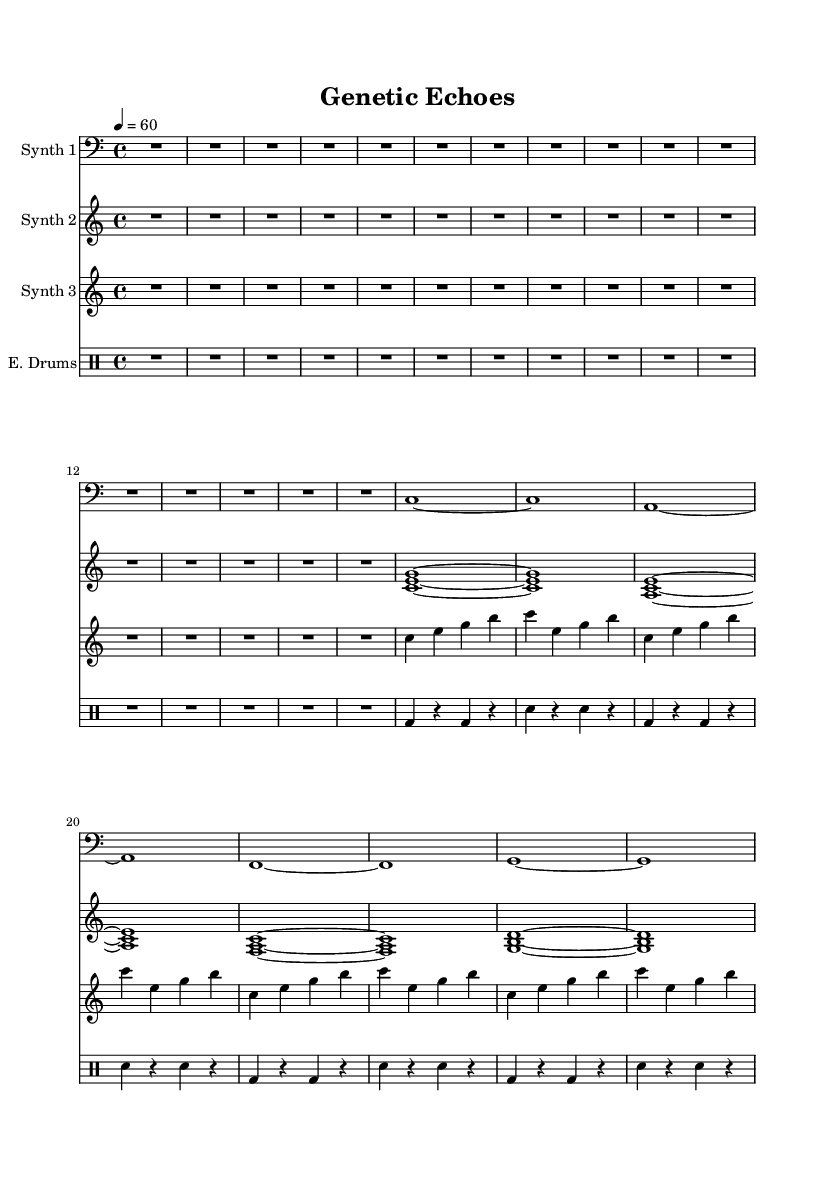What is the key signature of this music? The key signature is C major, which is indicated by the absence of any sharps or flats in the music.
Answer: C major What is the time signature of this piece? The time signature is found at the beginning of the score. It shows a 4/4, meaning there are four beats in each measure and the quarter note gets one beat.
Answer: 4/4 What is the tempo marking given in this music? The tempo is indicated as 4 = 60, which means each quarter note should be played at a speed of 60 beats per minute.
Answer: 60 Which instrument is assigned to the synth part with the bass clef? The instrument assigned to the synth part with the bass clef is labeled as "Synth 1," as indicated on the staff where its clef is shown.
Answer: Synth 1 How many distinct synthesizers are used in this composition? There are three distinct synthesizers indicated in the score, each assigned to a separate staff for Synth 1, Synth 2, and Synth 3.
Answer: Three What is the rhythmic pattern used by the drums? The rhythmic pattern used by the drums consists of a repeated cycle featuring bass drum and snare drum hits, represented by alternating beats in a four-bar phrase.
Answer: Alternating What sonic characteristic does the music explore that relates to its title "Genetic Echoes"? The title suggests an exploration of sound textures and layers that evoke the complexity and patterns of genetic sequences, representing an experimental soundscape.
Answer: Sound textures 